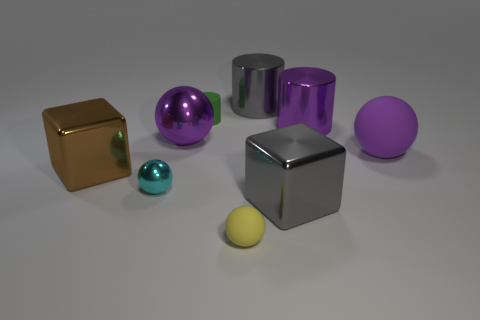Is there anything else that is the same material as the small cyan thing?
Offer a very short reply. Yes. What number of other things are the same size as the purple matte object?
Give a very brief answer. 5. There is a metallic ball that is the same color as the large rubber ball; what size is it?
Your answer should be compact. Large. How many metallic objects are the same color as the small matte sphere?
Your answer should be very brief. 0. What is the shape of the tiny cyan metallic thing?
Offer a very short reply. Sphere. There is a matte object that is to the left of the large gray cube and behind the brown metal block; what is its color?
Offer a terse response. Green. What is the material of the yellow object?
Provide a succinct answer. Rubber. The large purple object left of the tiny green thing has what shape?
Your response must be concise. Sphere. There is a matte ball that is the same size as the gray block; what color is it?
Make the answer very short. Purple. Do the ball right of the yellow ball and the cyan thing have the same material?
Your answer should be very brief. No. 